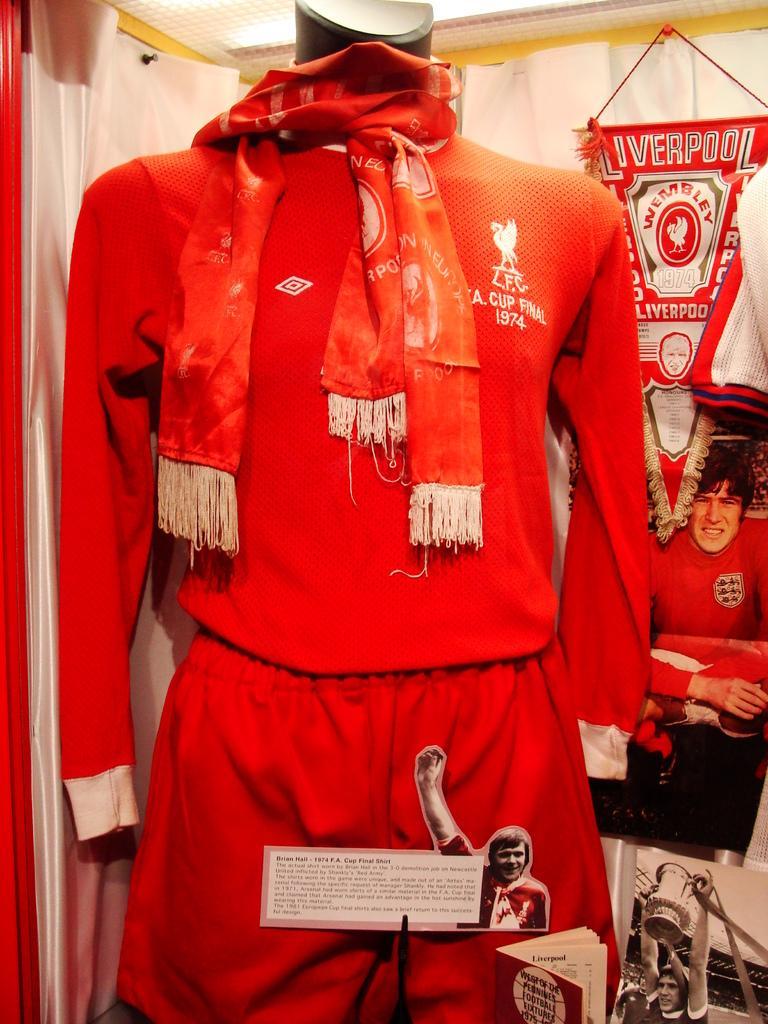Can you describe this image briefly? In this image there is a Liverpool jersey on a mannequin, behind the jersey on the curtain there is a poster, in front of the jersey there is a poster of a person with some text on it. 